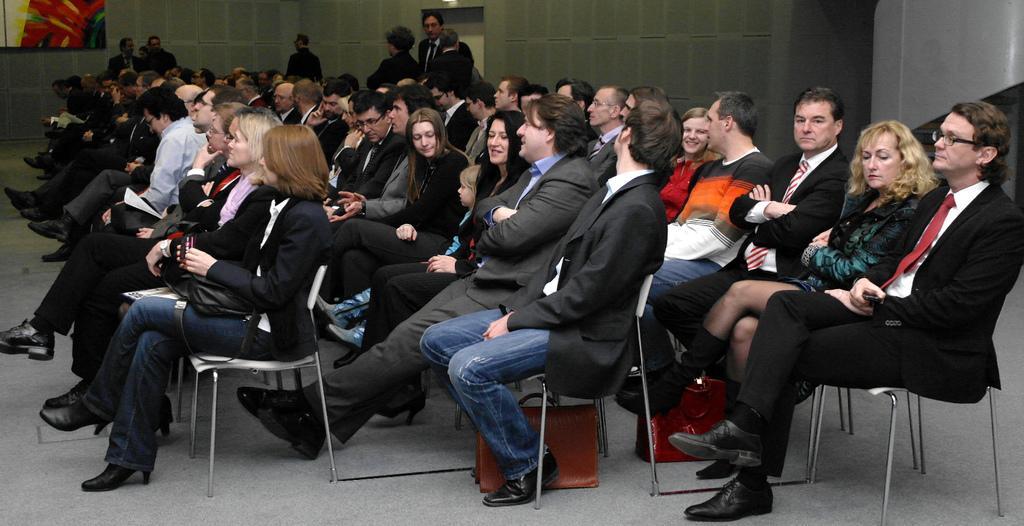How would you summarize this image in a sentence or two? This image is clicked inside a room. There are so many chairs and people are sitting in those chairs. There are bags at the bottom. There are women and men. There is a board in the top left corner. 